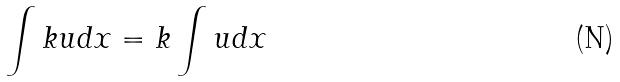Convert formula to latex. <formula><loc_0><loc_0><loc_500><loc_500>\int k u d x = k \int u d x</formula> 